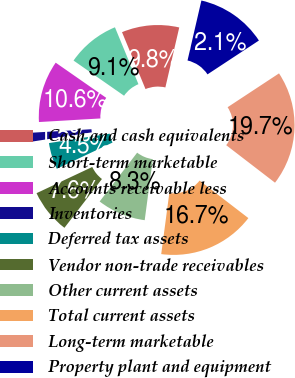Convert chart to OTSL. <chart><loc_0><loc_0><loc_500><loc_500><pie_chart><fcel>Cash and cash equivalents<fcel>Short-term marketable<fcel>Accounts receivable less<fcel>Inventories<fcel>Deferred tax assets<fcel>Vendor non-trade receivables<fcel>Other current assets<fcel>Total current assets<fcel>Long-term marketable<fcel>Property plant and equipment<nl><fcel>9.85%<fcel>9.09%<fcel>10.61%<fcel>1.52%<fcel>4.55%<fcel>7.58%<fcel>8.33%<fcel>16.67%<fcel>19.7%<fcel>12.12%<nl></chart> 